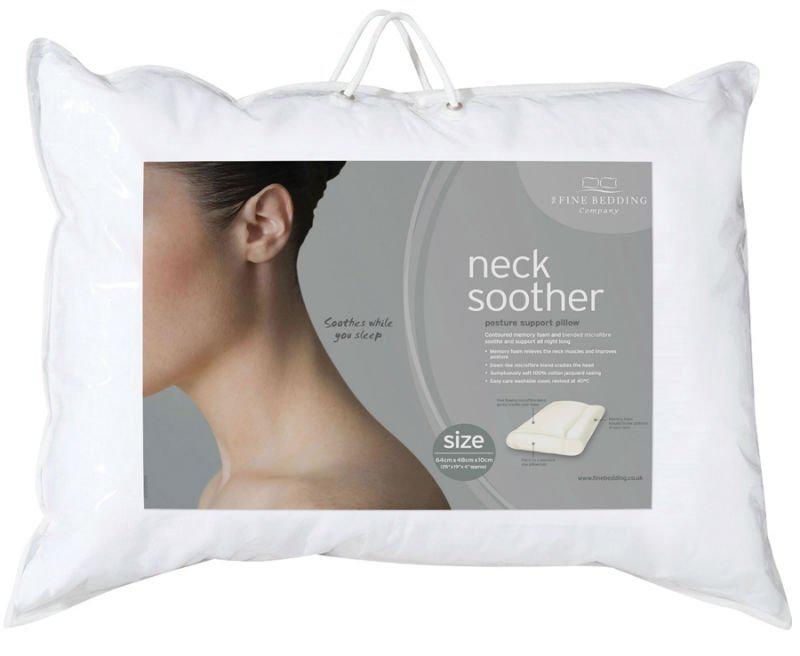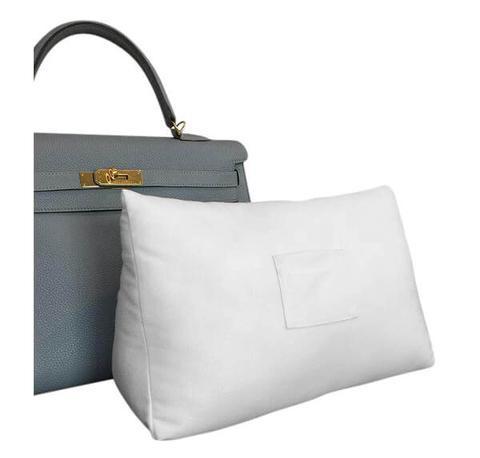The first image is the image on the left, the second image is the image on the right. For the images shown, is this caption "We see one pillow in the image on the right." true? Answer yes or no. Yes. The first image is the image on the left, the second image is the image on the right. Assess this claim about the two images: "there are humans in the right side pic". Correct or not? Answer yes or no. No. 